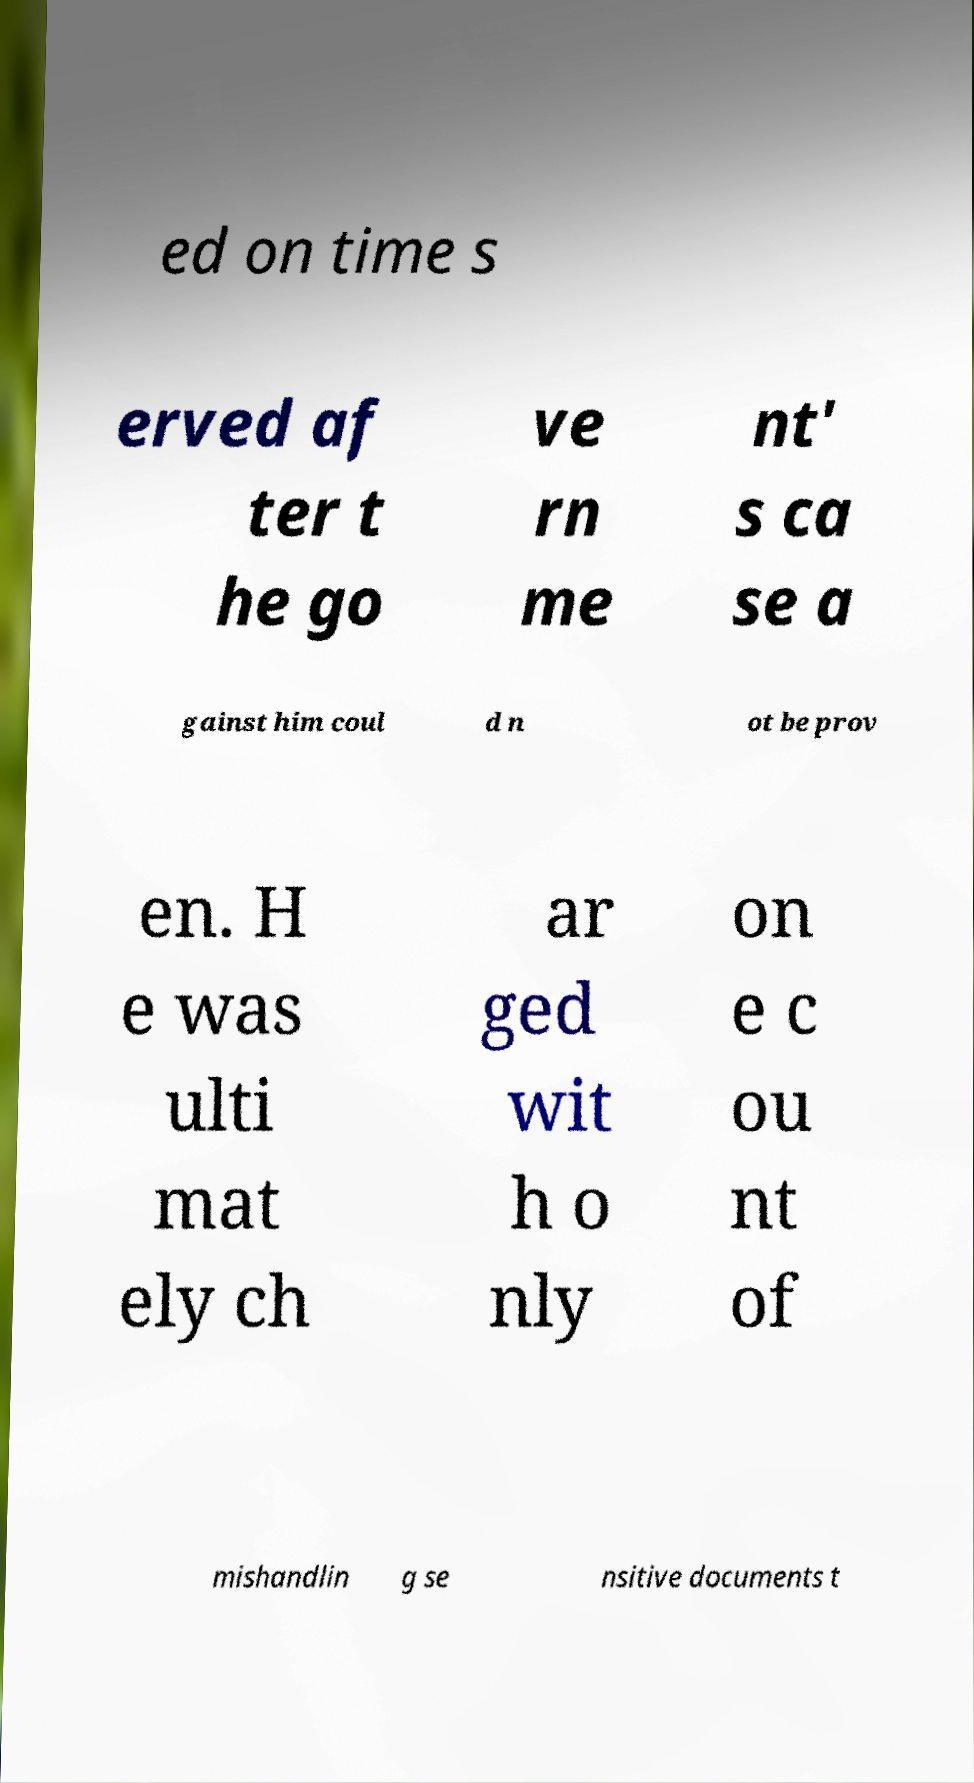I need the written content from this picture converted into text. Can you do that? ed on time s erved af ter t he go ve rn me nt' s ca se a gainst him coul d n ot be prov en. H e was ulti mat ely ch ar ged wit h o nly on e c ou nt of mishandlin g se nsitive documents t 